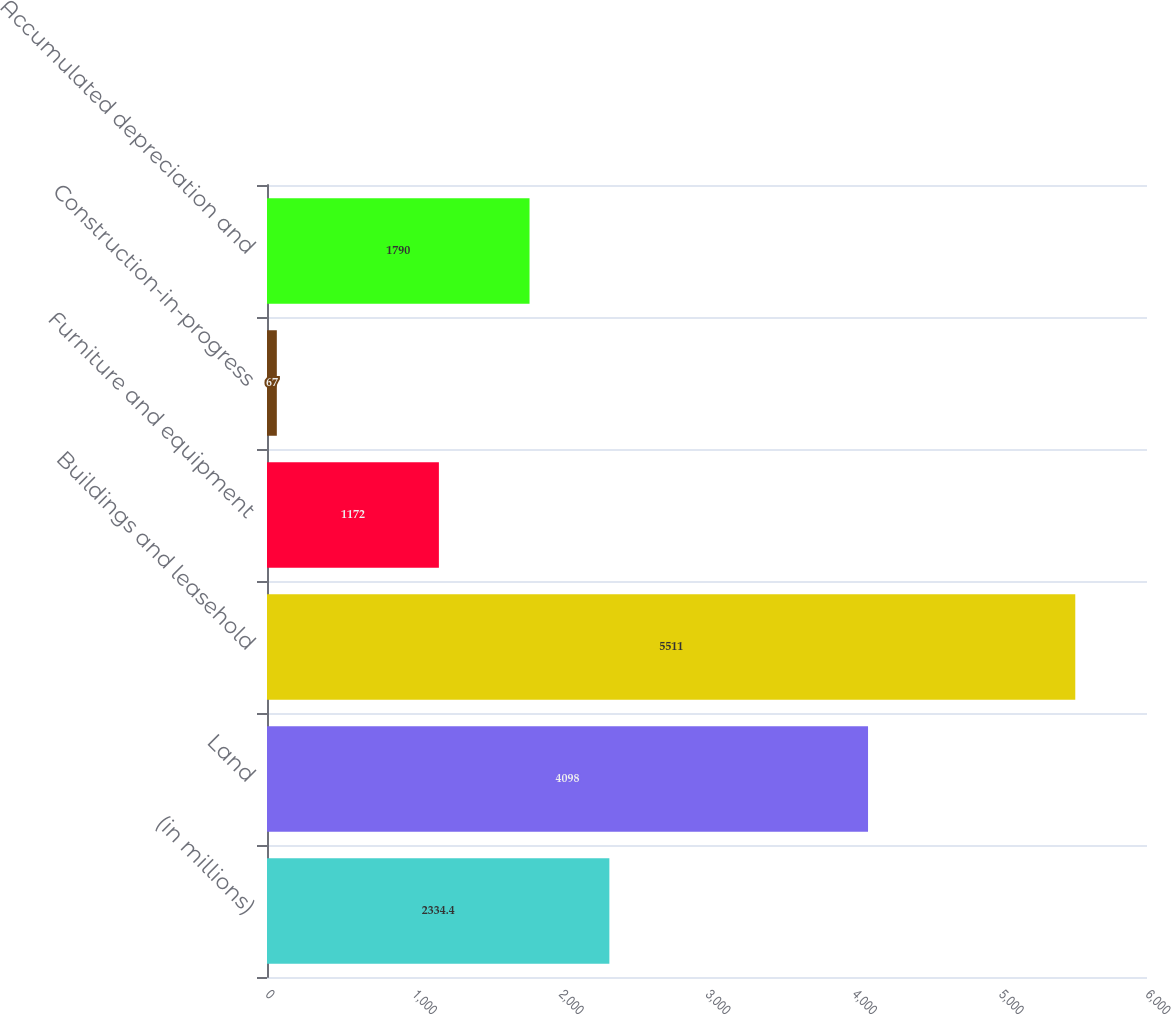Convert chart to OTSL. <chart><loc_0><loc_0><loc_500><loc_500><bar_chart><fcel>(in millions)<fcel>Land<fcel>Buildings and leasehold<fcel>Furniture and equipment<fcel>Construction-in-progress<fcel>Accumulated depreciation and<nl><fcel>2334.4<fcel>4098<fcel>5511<fcel>1172<fcel>67<fcel>1790<nl></chart> 